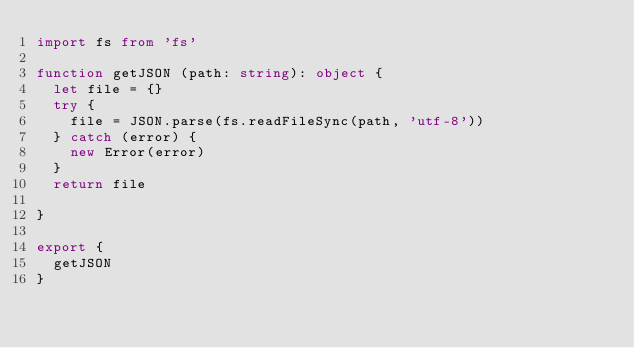Convert code to text. <code><loc_0><loc_0><loc_500><loc_500><_TypeScript_>import fs from 'fs'

function getJSON (path: string): object {
  let file = {}
  try {
    file = JSON.parse(fs.readFileSync(path, 'utf-8'))
  } catch (error) {
    new Error(error)
  }
  return file

}

export {
  getJSON
}</code> 